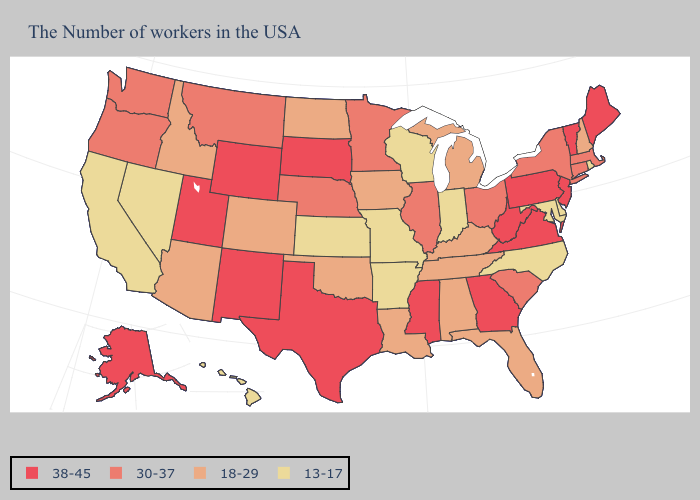Name the states that have a value in the range 13-17?
Write a very short answer. Rhode Island, Delaware, Maryland, North Carolina, Indiana, Wisconsin, Missouri, Arkansas, Kansas, Nevada, California, Hawaii. Among the states that border Maryland , does Delaware have the highest value?
Concise answer only. No. What is the highest value in the MidWest ?
Keep it brief. 38-45. Among the states that border Connecticut , which have the highest value?
Keep it brief. Massachusetts, New York. What is the lowest value in states that border Wisconsin?
Write a very short answer. 18-29. What is the highest value in states that border Idaho?
Give a very brief answer. 38-45. Does Wyoming have the lowest value in the West?
Concise answer only. No. How many symbols are there in the legend?
Give a very brief answer. 4. How many symbols are there in the legend?
Be succinct. 4. Name the states that have a value in the range 38-45?
Write a very short answer. Maine, Vermont, New Jersey, Pennsylvania, Virginia, West Virginia, Georgia, Mississippi, Texas, South Dakota, Wyoming, New Mexico, Utah, Alaska. Name the states that have a value in the range 13-17?
Keep it brief. Rhode Island, Delaware, Maryland, North Carolina, Indiana, Wisconsin, Missouri, Arkansas, Kansas, Nevada, California, Hawaii. Name the states that have a value in the range 38-45?
Be succinct. Maine, Vermont, New Jersey, Pennsylvania, Virginia, West Virginia, Georgia, Mississippi, Texas, South Dakota, Wyoming, New Mexico, Utah, Alaska. Name the states that have a value in the range 13-17?
Be succinct. Rhode Island, Delaware, Maryland, North Carolina, Indiana, Wisconsin, Missouri, Arkansas, Kansas, Nevada, California, Hawaii. Which states have the highest value in the USA?
Keep it brief. Maine, Vermont, New Jersey, Pennsylvania, Virginia, West Virginia, Georgia, Mississippi, Texas, South Dakota, Wyoming, New Mexico, Utah, Alaska. Name the states that have a value in the range 38-45?
Short answer required. Maine, Vermont, New Jersey, Pennsylvania, Virginia, West Virginia, Georgia, Mississippi, Texas, South Dakota, Wyoming, New Mexico, Utah, Alaska. 